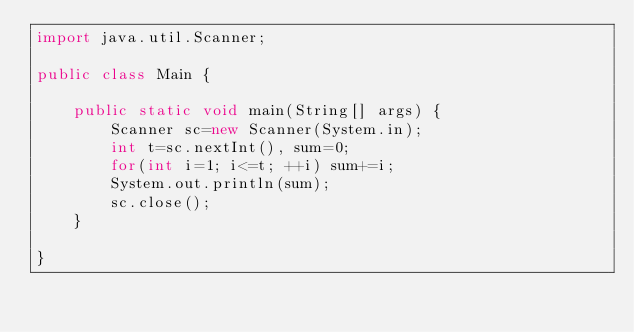Convert code to text. <code><loc_0><loc_0><loc_500><loc_500><_Java_>import java.util.Scanner;

public class Main {

	public static void main(String[] args) {
		Scanner sc=new Scanner(System.in);
		int t=sc.nextInt(), sum=0;
		for(int i=1; i<=t; ++i) sum+=i;
		System.out.println(sum);
		sc.close(); 
	}

}
</code> 